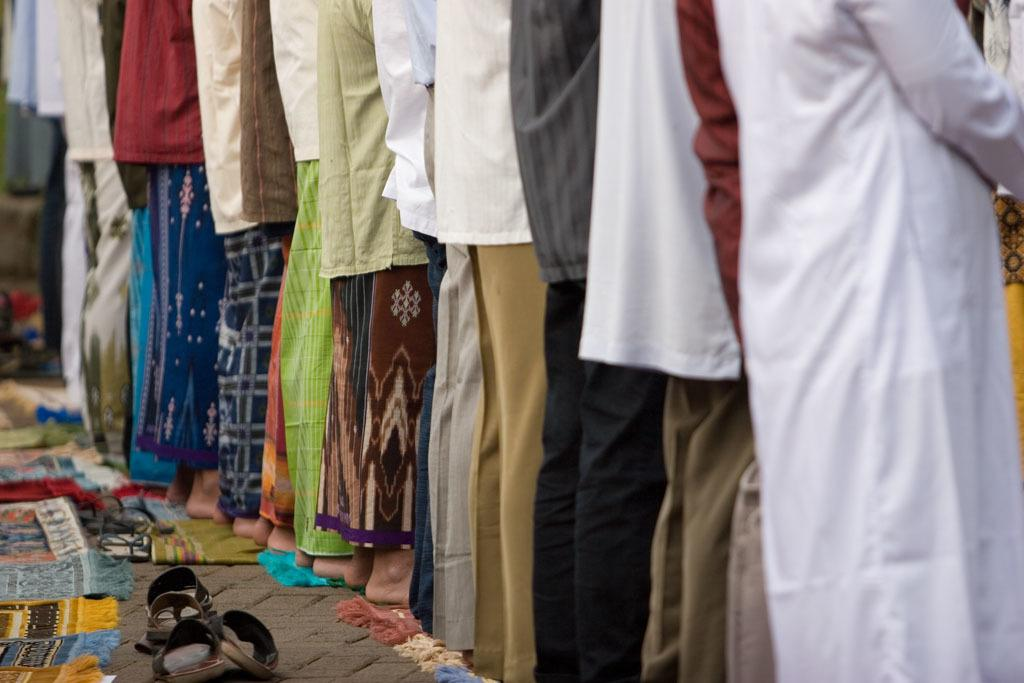What are the men in the image doing? The men in the image are standing in a line. What objects can be seen behind the men in the image? There are slippers visible behind the men in the image. What type of sack can be seen being carried by the company in the image? There is no sack or company present in the image. What type of society is depicted in the image? The image does not depict any specific society; it simply shows men standing in a line with slippers visible behind them. 